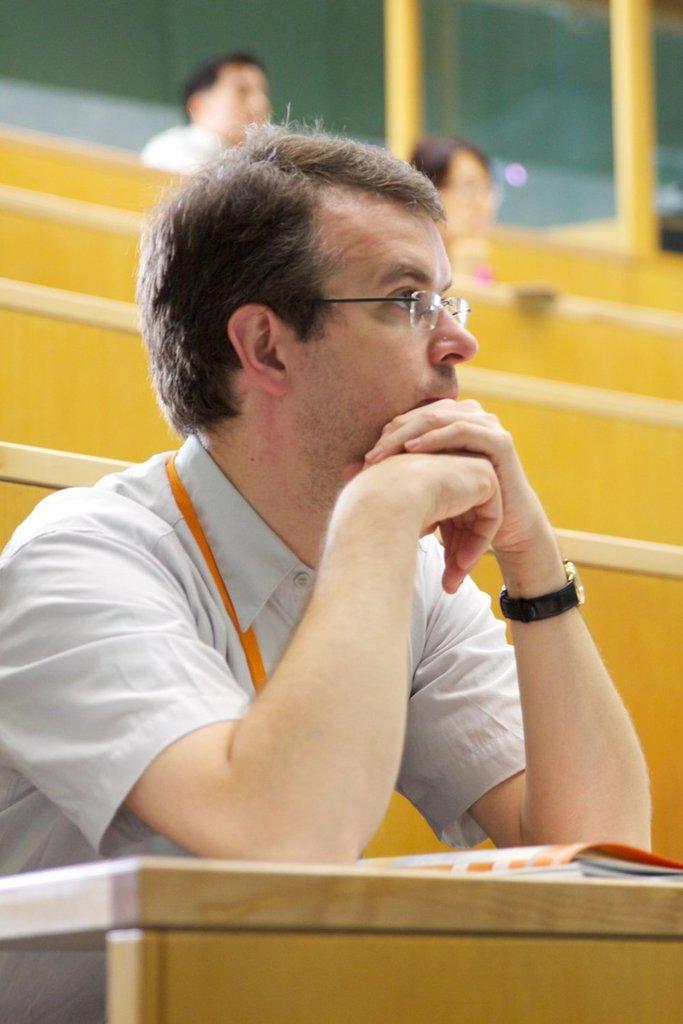Can you describe this image briefly? In this image there is a person wearing goggles and a watch and sitting on one of the benches, there is a book in front of the person, behind him there are two people and pillars. 